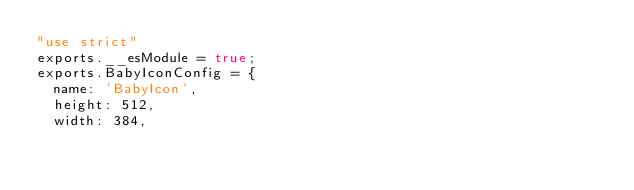Convert code to text. <code><loc_0><loc_0><loc_500><loc_500><_JavaScript_>"use strict"
exports.__esModule = true;
exports.BabyIconConfig = {
  name: 'BabyIcon',
  height: 512,
  width: 384,</code> 